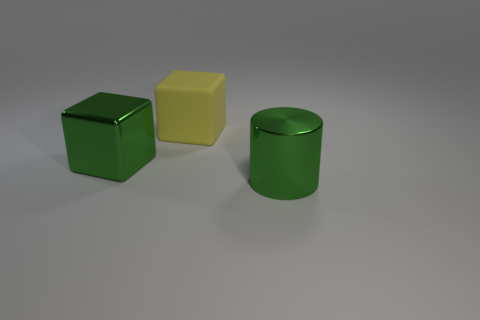Subtract all yellow blocks. How many blocks are left? 1 Add 1 green blocks. How many green blocks are left? 2 Add 3 big gray matte objects. How many big gray matte objects exist? 3 Add 3 metal objects. How many objects exist? 6 Subtract 1 yellow cubes. How many objects are left? 2 Subtract all blocks. How many objects are left? 1 Subtract 2 blocks. How many blocks are left? 0 Subtract all yellow cubes. Subtract all green cylinders. How many cubes are left? 1 Subtract all yellow cylinders. How many yellow blocks are left? 1 Subtract all large yellow objects. Subtract all small brown rubber objects. How many objects are left? 2 